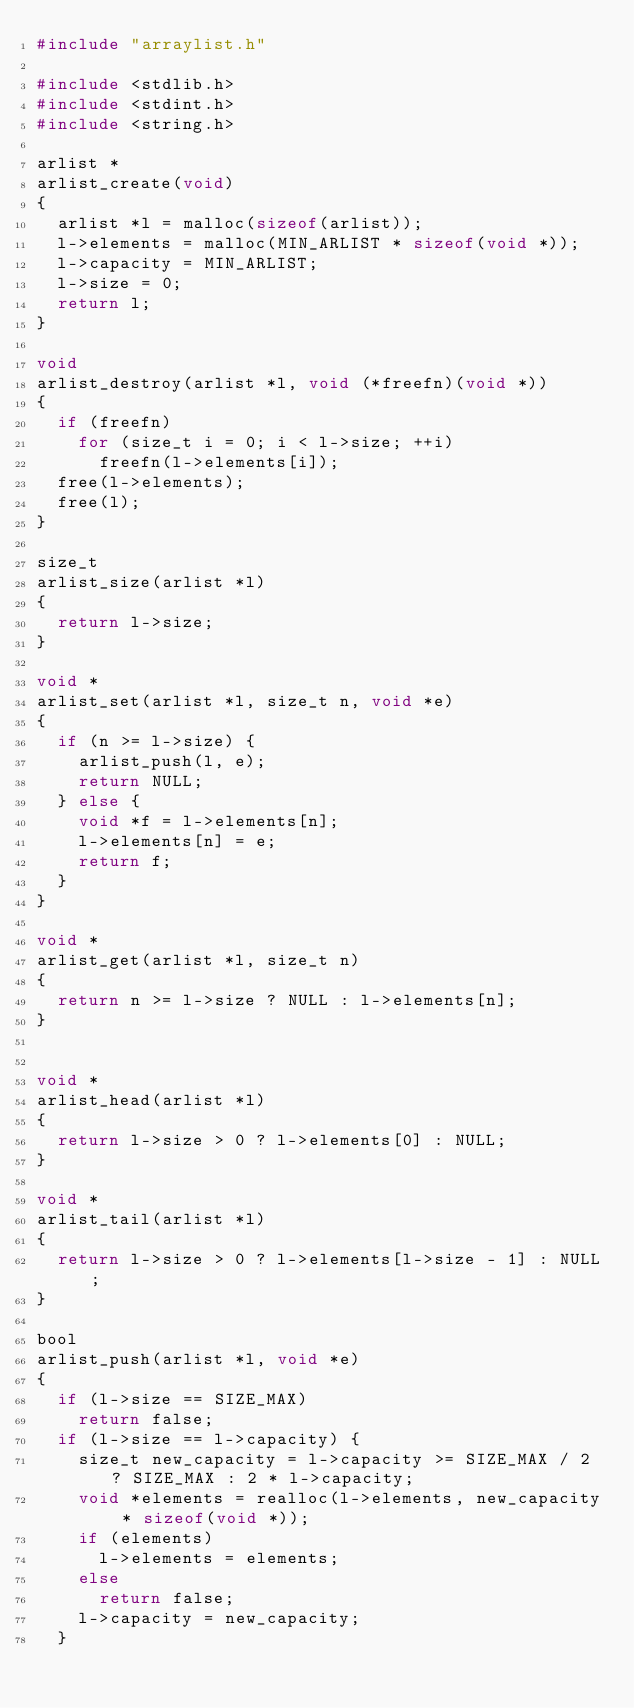<code> <loc_0><loc_0><loc_500><loc_500><_C_>#include "arraylist.h"

#include <stdlib.h>
#include <stdint.h>
#include <string.h>

arlist *
arlist_create(void)
{
	arlist *l = malloc(sizeof(arlist));
	l->elements = malloc(MIN_ARLIST * sizeof(void *));
	l->capacity = MIN_ARLIST;
	l->size = 0;
	return l;
}

void
arlist_destroy(arlist *l, void (*freefn)(void *))
{
	if (freefn)
		for (size_t i = 0; i < l->size; ++i)
			freefn(l->elements[i]);
	free(l->elements);
	free(l);
}

size_t
arlist_size(arlist *l)
{
	return l->size;
}

void *
arlist_set(arlist *l, size_t n, void *e)
{
	if (n >= l->size) {
		arlist_push(l, e);
		return NULL;
	} else {
		void *f = l->elements[n];
		l->elements[n] = e;
		return f;
	}
}

void *
arlist_get(arlist *l, size_t n)
{
	return n >= l->size ? NULL : l->elements[n];
}


void *
arlist_head(arlist *l)
{
	return l->size > 0 ? l->elements[0] : NULL;
}

void *
arlist_tail(arlist *l)
{
	return l->size > 0 ? l->elements[l->size - 1] : NULL;
}

bool
arlist_push(arlist *l, void *e)
{
	if (l->size == SIZE_MAX)
		return false;
	if (l->size == l->capacity) {
		size_t new_capacity = l->capacity >= SIZE_MAX / 2 ? SIZE_MAX : 2 * l->capacity;
		void *elements = realloc(l->elements, new_capacity * sizeof(void *));
		if (elements)
			l->elements = elements;
		else
			return false;
		l->capacity = new_capacity;
	}</code> 